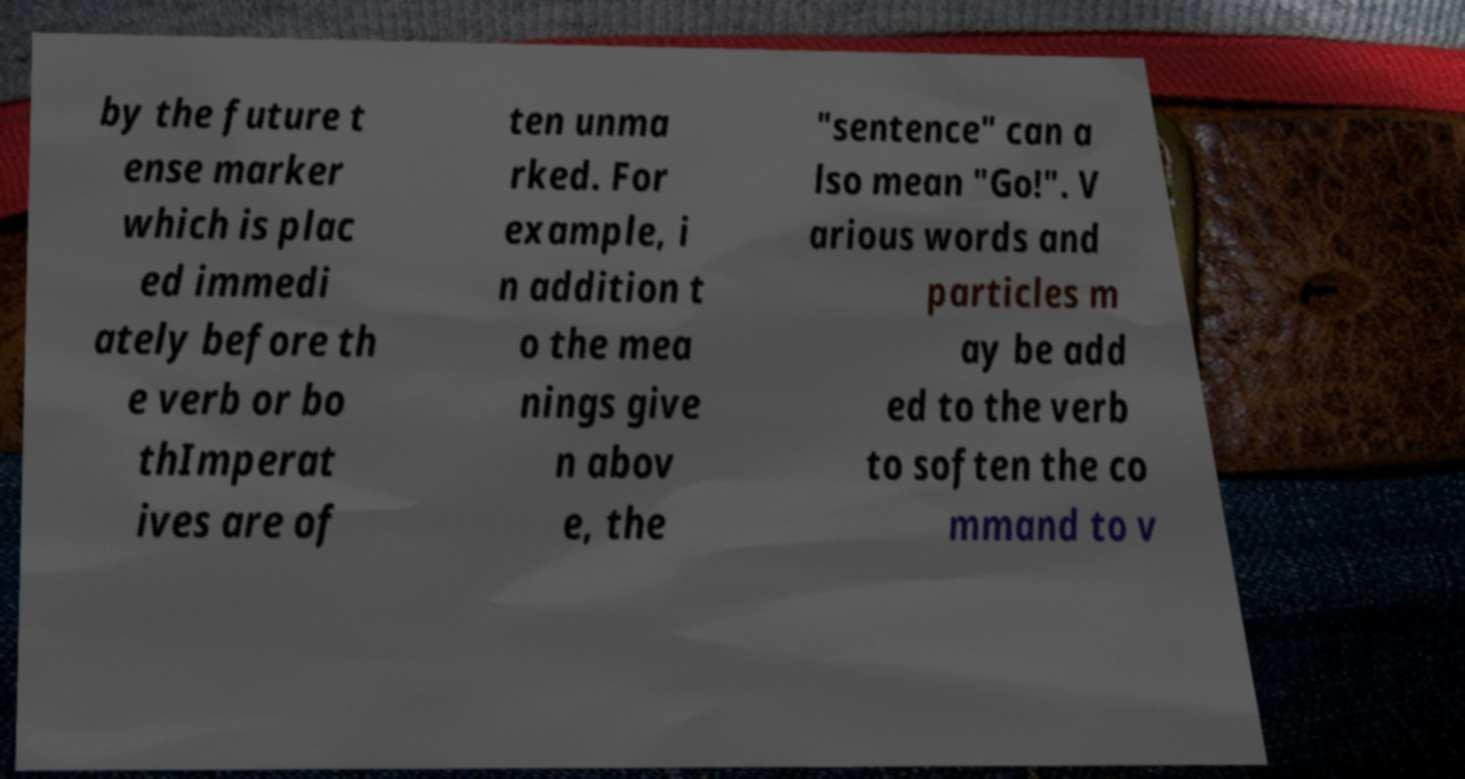What messages or text are displayed in this image? I need them in a readable, typed format. by the future t ense marker which is plac ed immedi ately before th e verb or bo thImperat ives are of ten unma rked. For example, i n addition t o the mea nings give n abov e, the "sentence" can a lso mean "Go!". V arious words and particles m ay be add ed to the verb to soften the co mmand to v 